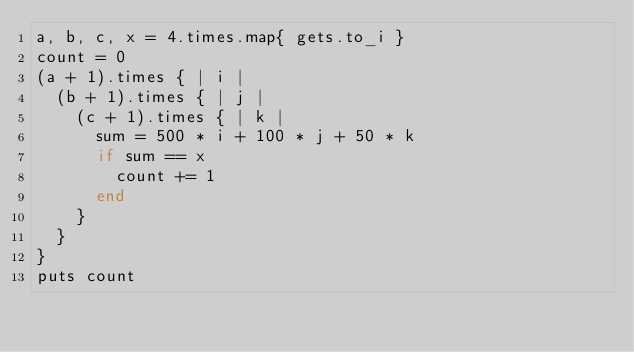<code> <loc_0><loc_0><loc_500><loc_500><_Ruby_>a, b, c, x = 4.times.map{ gets.to_i }
count = 0
(a + 1).times { | i |
  (b + 1).times { | j |
    (c + 1).times { | k |
      sum = 500 * i + 100 * j + 50 * k
      if sum == x
        count += 1
      end
    }
  }
}
puts count</code> 